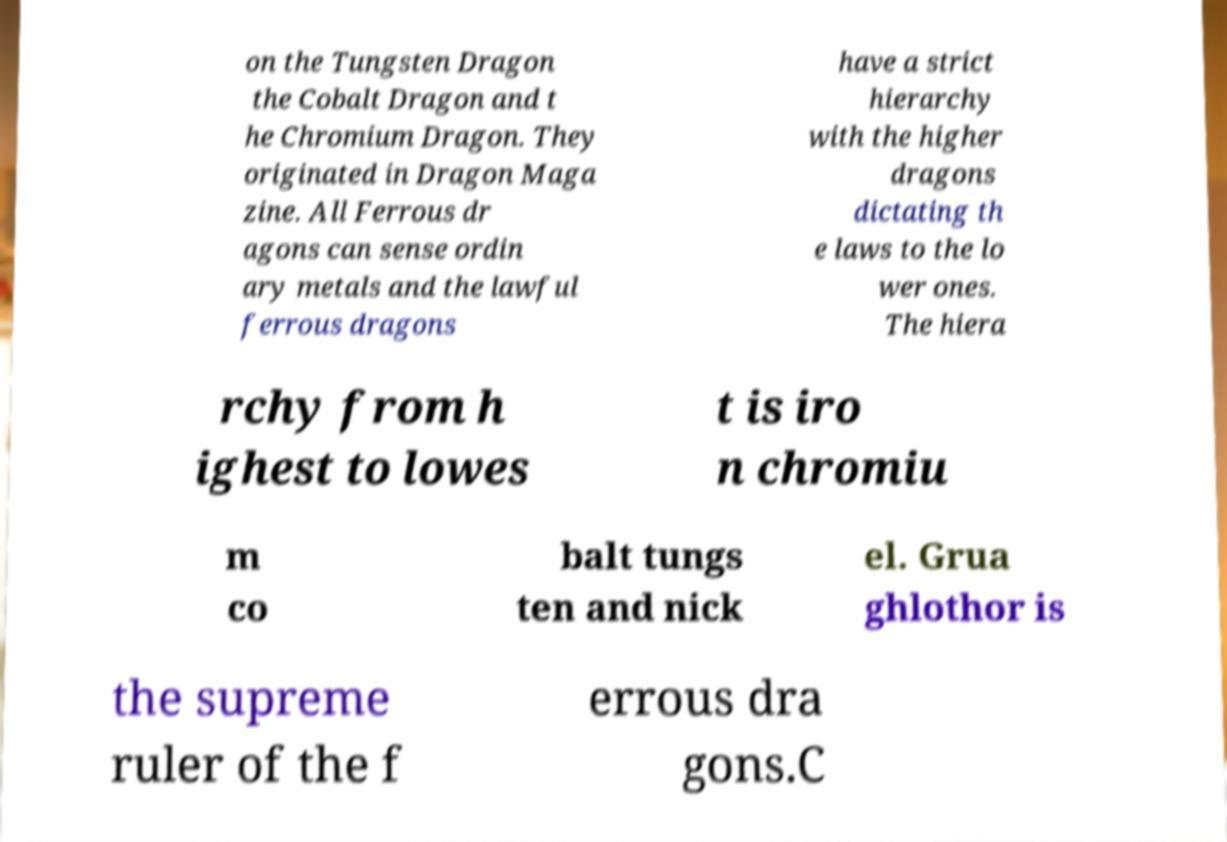For documentation purposes, I need the text within this image transcribed. Could you provide that? on the Tungsten Dragon the Cobalt Dragon and t he Chromium Dragon. They originated in Dragon Maga zine. All Ferrous dr agons can sense ordin ary metals and the lawful ferrous dragons have a strict hierarchy with the higher dragons dictating th e laws to the lo wer ones. The hiera rchy from h ighest to lowes t is iro n chromiu m co balt tungs ten and nick el. Grua ghlothor is the supreme ruler of the f errous dra gons.C 